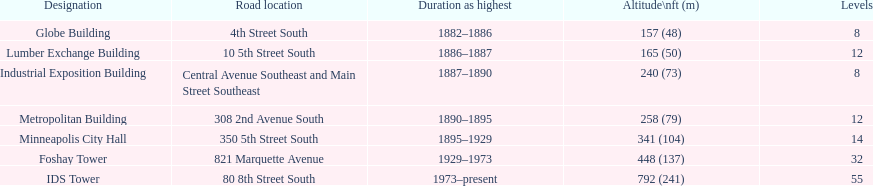Is the metropolitan building or the lumber exchange building taller? Metropolitan Building. 